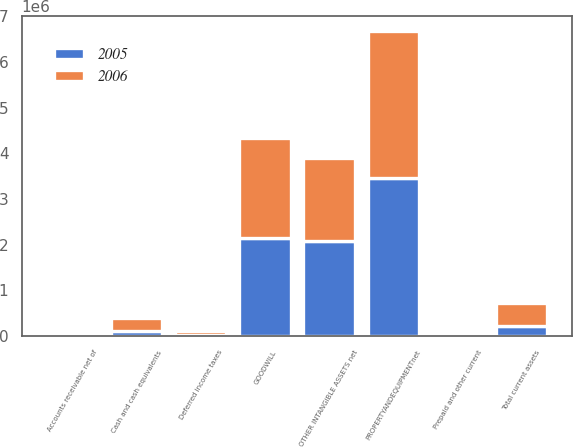Convert chart. <chart><loc_0><loc_0><loc_500><loc_500><stacked_bar_chart><ecel><fcel>Cash and cash equivalents<fcel>Accounts receivable net of<fcel>Prepaid and other current<fcel>Deferred income taxes<fcel>Total current assets<fcel>PROPERTYANDEQUIPMENTnet<fcel>GOODWILL<fcel>OTHER INTANGIBLE ASSETS net<nl><fcel>2006<fcel>281264<fcel>29368<fcel>63919<fcel>88485<fcel>486022<fcel>3.21812e+06<fcel>2.18977e+06<fcel>1.82088e+06<nl><fcel>2005<fcel>112701<fcel>36995<fcel>44823<fcel>31359<fcel>225878<fcel>3.46053e+06<fcel>2.14255e+06<fcel>2.07731e+06<nl></chart> 